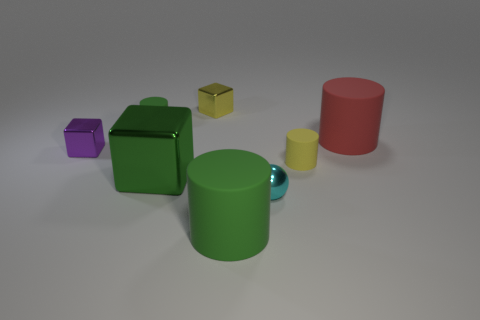There is a large block; is it the same color as the small rubber object behind the large red cylinder?
Ensure brevity in your answer.  Yes. Is the red rubber thing the same shape as the cyan thing?
Keep it short and to the point. No. The green object that is the same shape as the tiny yellow metallic object is what size?
Offer a very short reply. Large. Is the size of the rubber cylinder that is in front of the yellow rubber object the same as the cyan ball?
Give a very brief answer. No. What size is the shiny object that is both in front of the tiny purple block and left of the large green cylinder?
Provide a short and direct response. Large. There is a small cylinder that is the same color as the large metallic cube; what is its material?
Offer a very short reply. Rubber. What number of small things have the same color as the big shiny object?
Provide a succinct answer. 1. Is the number of tiny yellow rubber cylinders that are right of the tiny green object the same as the number of red matte objects?
Your response must be concise. Yes. What is the color of the tiny ball?
Your answer should be very brief. Cyan. The green thing that is made of the same material as the small cyan ball is what size?
Your answer should be compact. Large. 